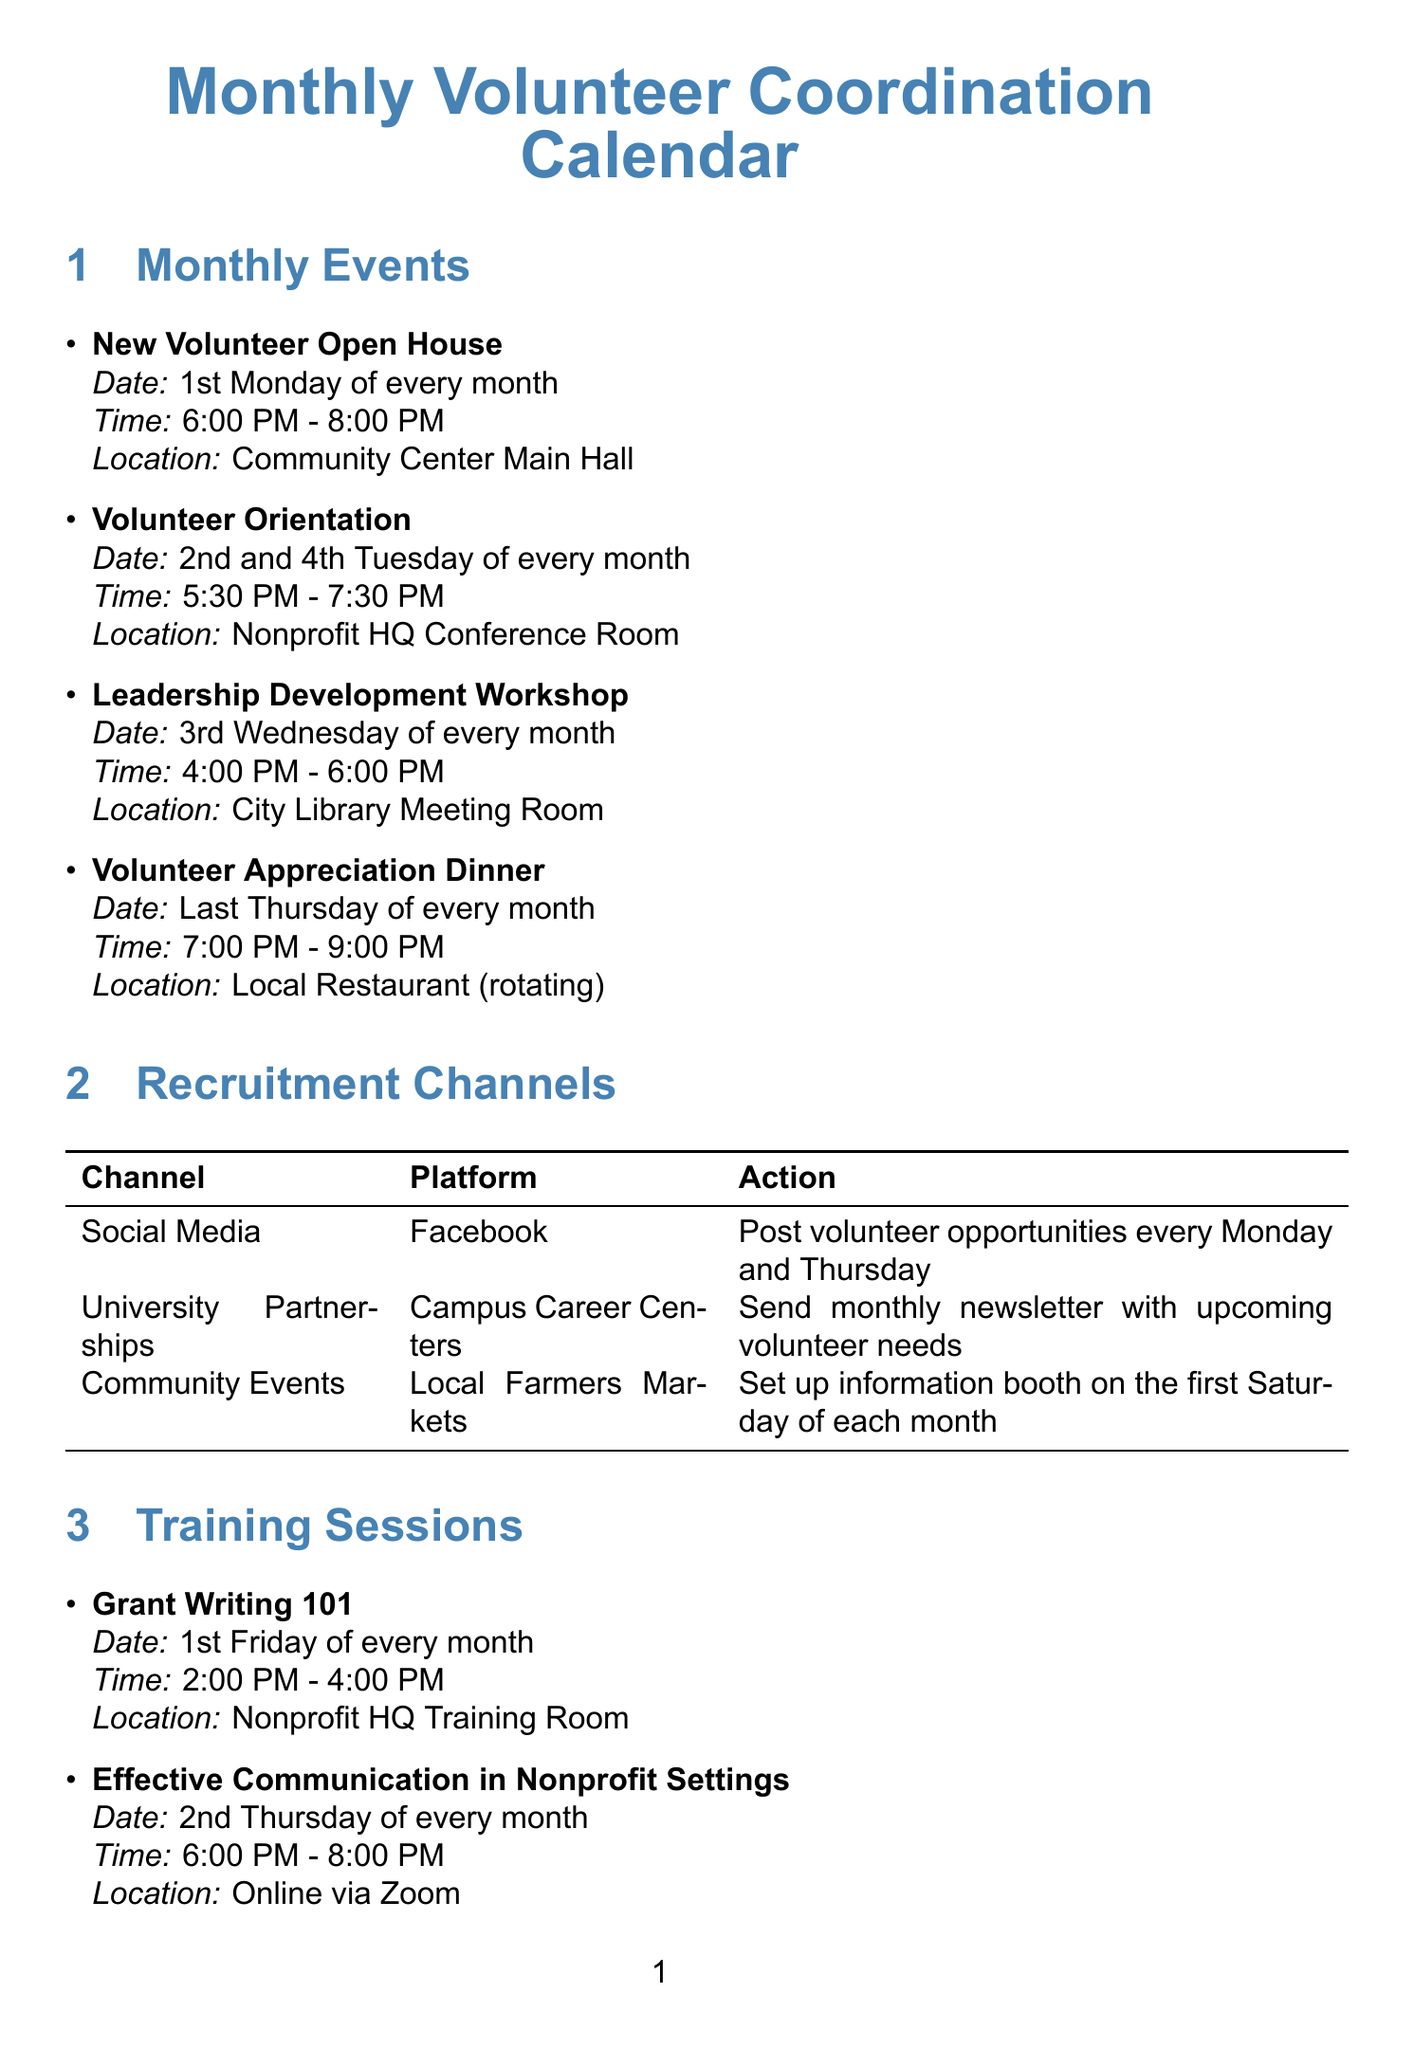what is the location of the Volunteer Orientation? The location of the Volunteer Orientation is mentioned under the Monthly Events section as Nonprofit HQ Conference Room.
Answer: Nonprofit HQ Conference Room what day is the Volunteer Appreciation Dinner scheduled? The Volunteer Appreciation Dinner is scheduled on the last Thursday of every month, which is explicitly stated in the Monthly Events section.
Answer: Last Thursday who is responsible for posting volunteer opportunities on Facebook? The document indicates that the Marketing Coordinator is responsible for posting volunteer opportunities every Monday and Thursday on Facebook, as noted in the Recruitment Channels section.
Answer: Marketing Coordinator how often is the Grant Writing 101 session held? The session is held on the 1st Friday of every month, which can be found in the Training Sessions section.
Answer: Every month when is the Annual Fundraising Gala? The document specifies that the Annual Fundraising Gala occurs on the 2nd Saturday in October in the Key Dates section.
Answer: 2nd Saturday in October what is required to attend the Volunteer Orientation? The Volunteer Orientation is described as a mandatory training session for all new volunteers, indicating that attendance is required.
Answer: Mandatory which event takes place at the City Library Meeting Room? The Leadership Development Workshop is scheduled to take place at the City Library Meeting Room, according to the Monthly Events section.
Answer: Leadership Development Workshop how many training sessions are scheduled in a month? There are three training sessions scheduled each month according to the Training Sessions section, specifically listed.
Answer: Three what platform is used for the Effective Communication in Nonprofit Settings training? The training session is conducted online via Zoom as indicated in the Training Sessions section.
Answer: Online via Zoom 